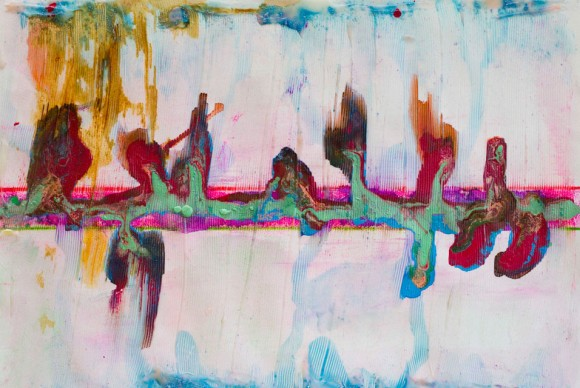What emotions does this abstract art evoke in you? This abstract art evokes a serene yet complex blend of emotions. The pastel colors bring a sense of tranquility and calmness, while the darker shades introduce a hint of mystery and depth. The dynamic composition speaks of movement and energy, making one feel both relaxed and intrigued. How do you think the artist achieved the texture in this piece? The texture in this piece likely results from a combination of different artistic techniques. It appears the artist used various mediums, including paint and possibly collage elements. The layering of these materials creates a rich, tactile surface. Techniques like impasto, where paint is applied thickly, and possibly even scraping or dragging tools through wet paint, could contribute to the textured effect. This tactile dimension adds to the viewer's tactile experience, enhancing the overall visual impact of the artwork. 